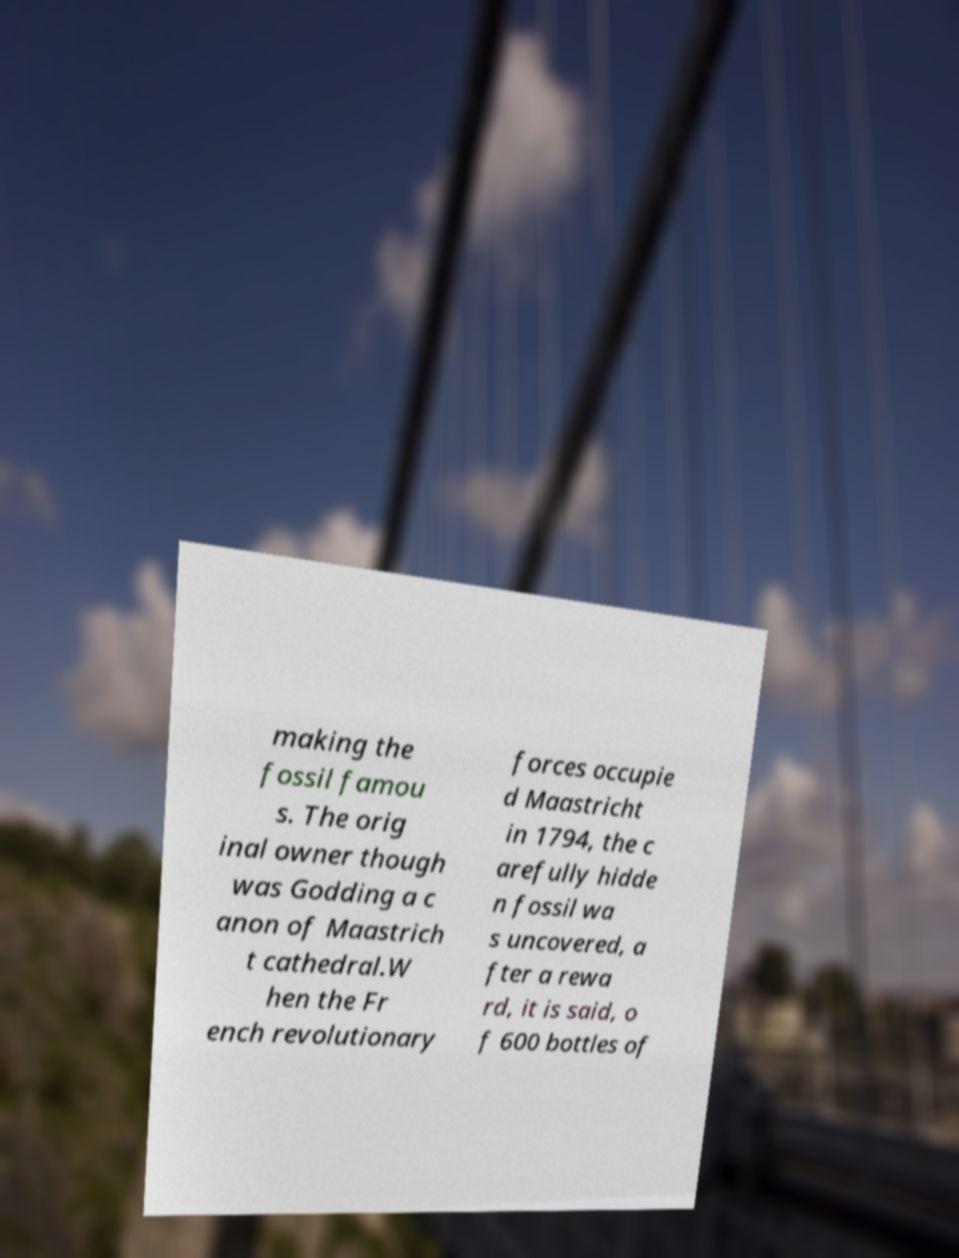What messages or text are displayed in this image? I need them in a readable, typed format. making the fossil famou s. The orig inal owner though was Godding a c anon of Maastrich t cathedral.W hen the Fr ench revolutionary forces occupie d Maastricht in 1794, the c arefully hidde n fossil wa s uncovered, a fter a rewa rd, it is said, o f 600 bottles of 